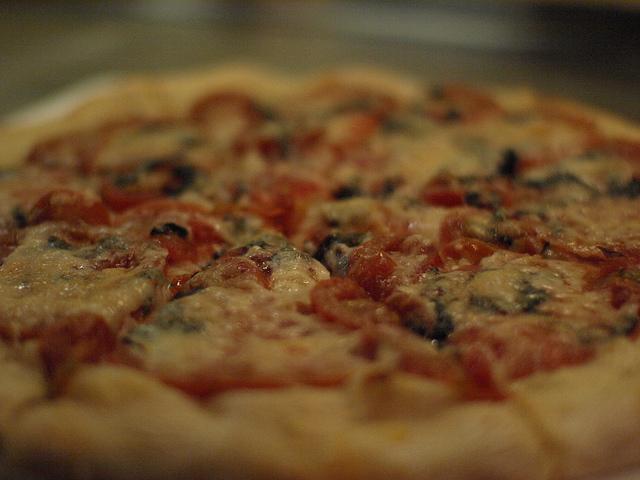How many slices have been picked?
Give a very brief answer. 0. How many pizzas are there?
Give a very brief answer. 2. How many sinks are in the bathroom?
Give a very brief answer. 0. 